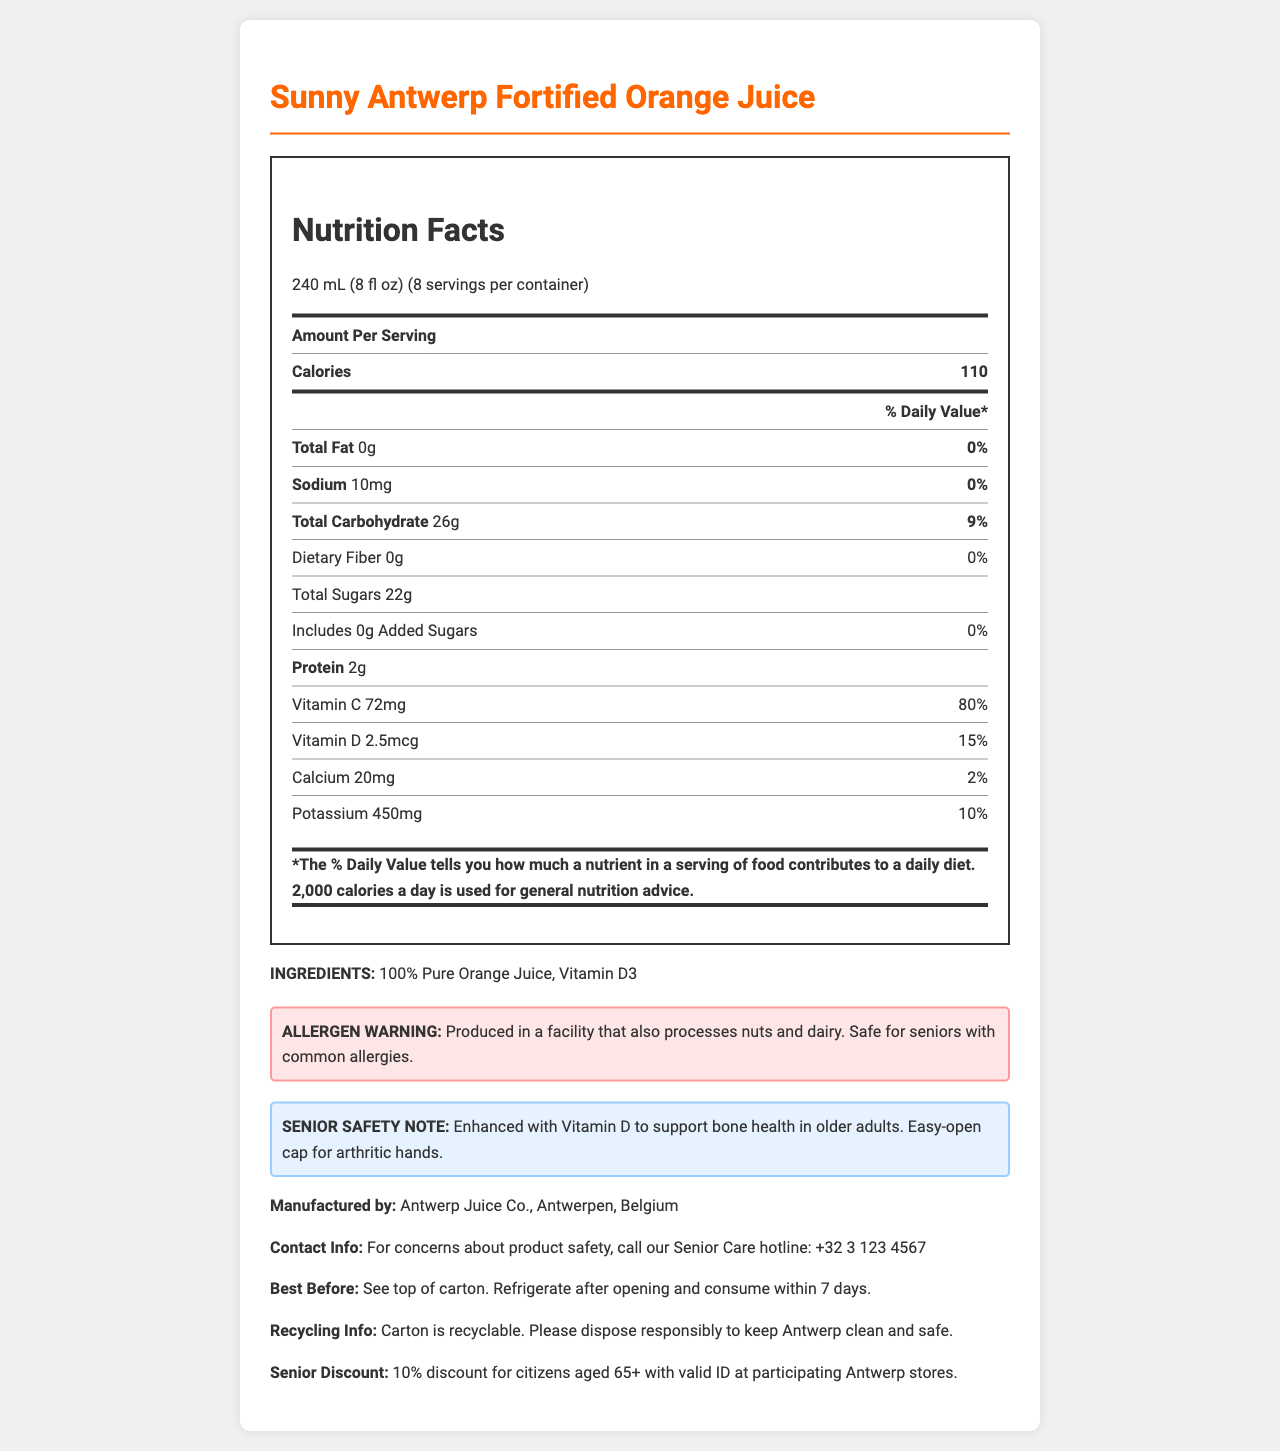what is the serving size? The serving size is listed at the beginning of the nutrition facts label.
Answer: 240 mL (8 fl oz) how many servings are in the container? The number of servings per container is mentioned alongside the serving size.
Answer: 8 how many calories are in one serving? The calories per serving are listed under the amount per serving section.
Answer: 110 what is the sodium content per serving? The sodium content is specified in the nutrition facts table.
Answer: 10mg does this juice contain any added sugars? The total sugars include 22g, and it is specified that there are 0g of added sugars.
Answer: No what is the primary ingredient in this juice? The ingredients section lists 100% Pure Orange Juice and Vitamin D3.
Answer: 100% Pure Orange Juice how much vitamin D is in one serving? The amount of vitamin D is shown in the nutrition facts table.
Answer: 2.5mcg what percentage of the daily value of potassium does one serving provide? This is indicated in the nutrition facts table under potassium.
Answer: 10% what should you do after opening the juice carton? A. Store it in the pantry B. Keep it at room temperature C. Refrigerate it The best before section advises to refrigerate after opening.
Answer: C how many grams of protein are in one serving? A. 1g B. 2g C. 3g The nutrition facts list protein as 2g per serving.
Answer: B does this product contain nuts or dairy? The allergen warning states it is produced in a facility that also processes nuts and dairy but does not directly contain these allergens.
Answer: No is this juice fortified with any vitamins? The juice is fortified with Vitamin D as stated in the product description and nutrition facts.
Answer: Yes can this document's information help determine the price of the juice? The document provides nutritional, ingredient, and safety information but does not mention the price.
Answer: Cannot be determined summarize the key features of the document. The detailed explanation covers product name, serving size, calories, specific nutrition contents, ingredients, allergen warnings, senior safety notes, manufacturing info, contact details, and additional notices like best before date and recycling info.
Answer: The document describes the nutrition facts of Sunny Antwerp Fortified Orange Juice, including serving size, calorie content, vitamin and mineral content, and allergen information. It highlights the juice's fortification with Vitamin D, suitability for seniors, and details about storage, allergens, and senior discounts. 